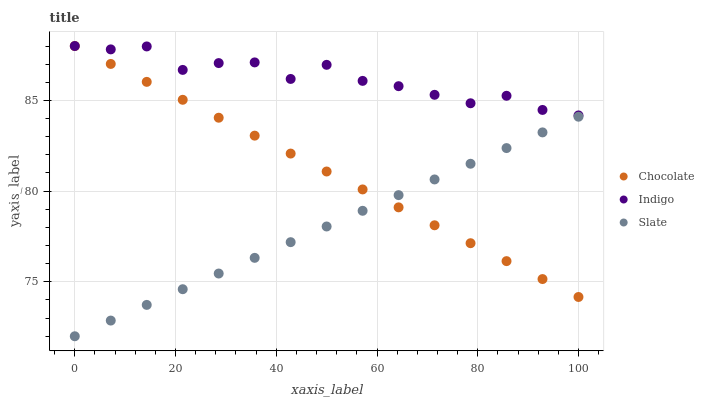Does Slate have the minimum area under the curve?
Answer yes or no. Yes. Does Indigo have the maximum area under the curve?
Answer yes or no. Yes. Does Chocolate have the minimum area under the curve?
Answer yes or no. No. Does Chocolate have the maximum area under the curve?
Answer yes or no. No. Is Slate the smoothest?
Answer yes or no. Yes. Is Indigo the roughest?
Answer yes or no. Yes. Is Chocolate the smoothest?
Answer yes or no. No. Is Chocolate the roughest?
Answer yes or no. No. Does Slate have the lowest value?
Answer yes or no. Yes. Does Chocolate have the lowest value?
Answer yes or no. No. Does Chocolate have the highest value?
Answer yes or no. Yes. Is Slate less than Indigo?
Answer yes or no. Yes. Is Indigo greater than Slate?
Answer yes or no. Yes. Does Chocolate intersect Indigo?
Answer yes or no. Yes. Is Chocolate less than Indigo?
Answer yes or no. No. Is Chocolate greater than Indigo?
Answer yes or no. No. Does Slate intersect Indigo?
Answer yes or no. No. 